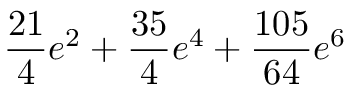<formula> <loc_0><loc_0><loc_500><loc_500>\frac { 2 1 } { 4 } e ^ { 2 } + \frac { 3 5 } { 4 } e ^ { 4 } + \frac { 1 0 5 } { 6 4 } e ^ { 6 }</formula> 